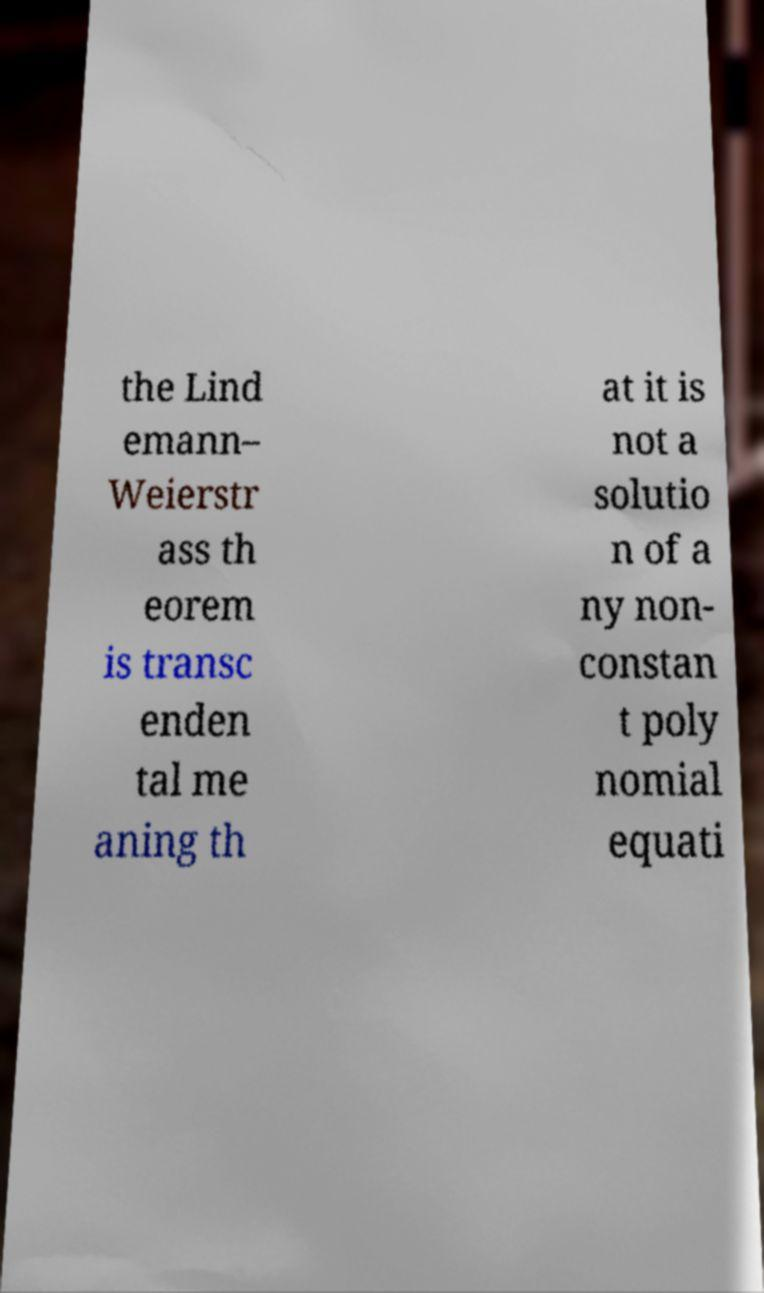Could you extract and type out the text from this image? the Lind emann– Weierstr ass th eorem is transc enden tal me aning th at it is not a solutio n of a ny non- constan t poly nomial equati 